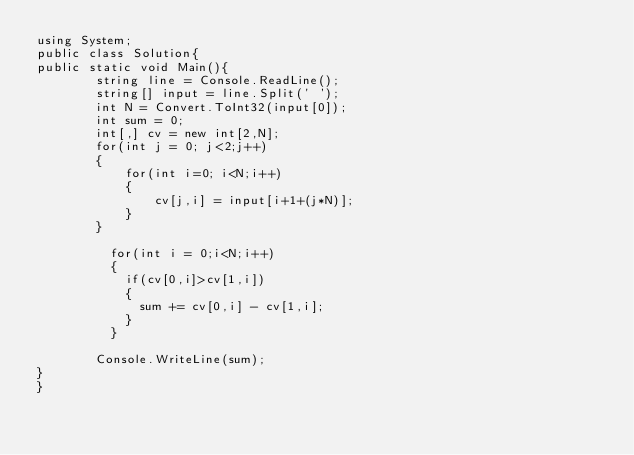Convert code to text. <code><loc_0><loc_0><loc_500><loc_500><_C#_>using System;
public class Solution{
public static void Main(){
  		string line = Console.ReadLine();
  		string[] input = line.Split(' ');
  		int N = Convert.ToInt32(input[0]);
  		int sum = 0;
  		int[,] cv = new int[2,N];
  		for(int j = 0; j<2;j++)
        {
  			for(int i=0; i<N;i++)
        	{  		
          		cv[j,i] = input[i+1+(j*N)];
        	}
        }
  	
          for(int i = 0;i<N;i++)
          {
            if(cv[0,i]>cv[1,i])
            {
              sum += cv[0,i] - cv[1,i];
            }
          }
        
  		Console.WriteLine(sum);
}
}</code> 